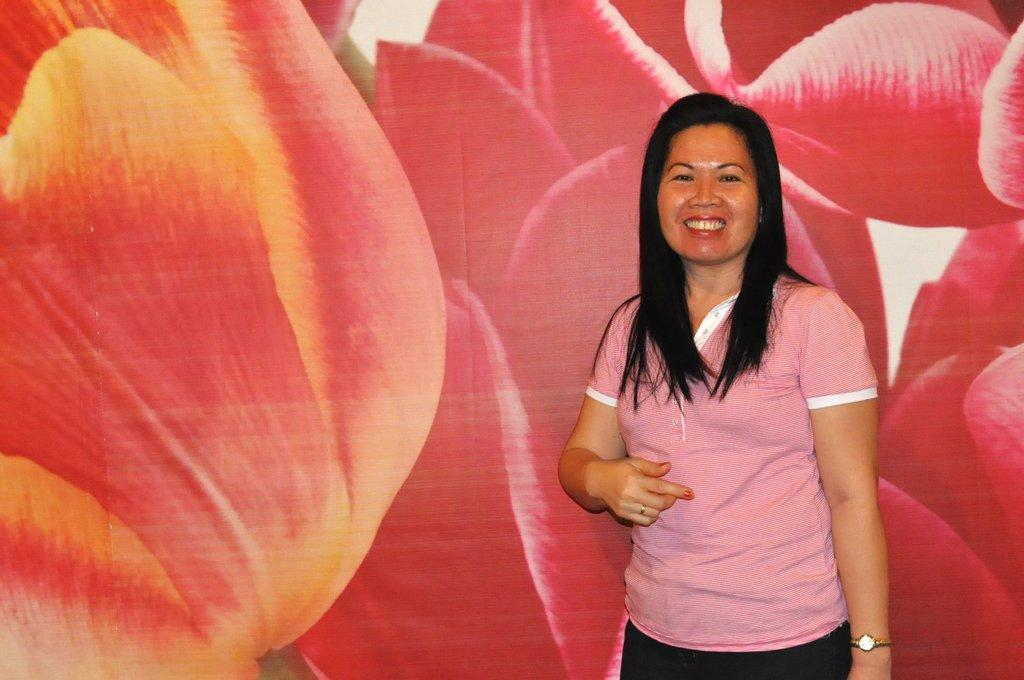What is the main subject of the image? There is a person in the image. What else can be seen in the image besides the person? There is a picture of flowers in the image. How many dolls are sitting on the cloud in the image? There are no dolls or clouds present in the image. 